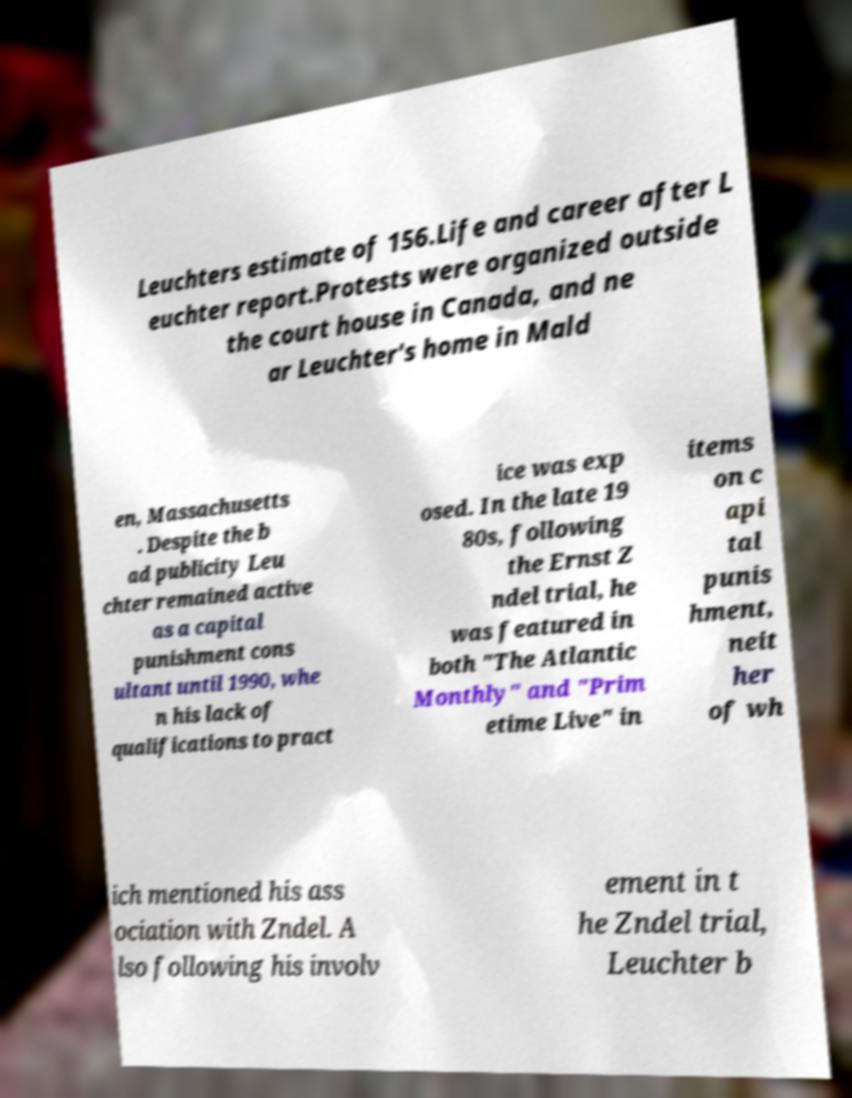Please read and relay the text visible in this image. What does it say? Leuchters estimate of 156.Life and career after L euchter report.Protests were organized outside the court house in Canada, and ne ar Leuchter's home in Mald en, Massachusetts . Despite the b ad publicity Leu chter remained active as a capital punishment cons ultant until 1990, whe n his lack of qualifications to pract ice was exp osed. In the late 19 80s, following the Ernst Z ndel trial, he was featured in both "The Atlantic Monthly" and "Prim etime Live" in items on c api tal punis hment, neit her of wh ich mentioned his ass ociation with Zndel. A lso following his involv ement in t he Zndel trial, Leuchter b 